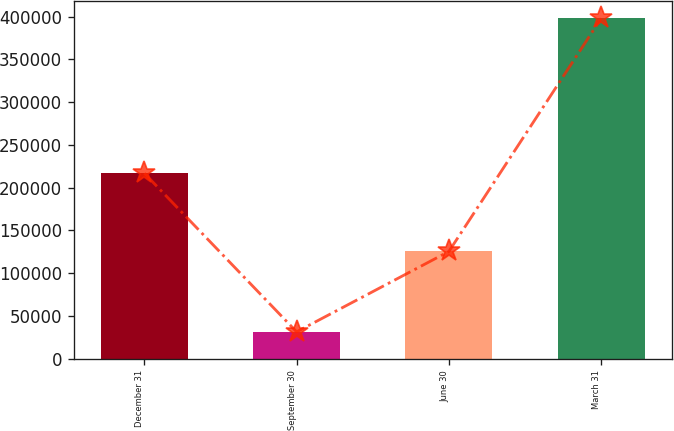Convert chart to OTSL. <chart><loc_0><loc_0><loc_500><loc_500><bar_chart><fcel>December 31<fcel>September 30<fcel>June 30<fcel>March 31<nl><fcel>216786<fcel>31430<fcel>125386<fcel>397922<nl></chart> 